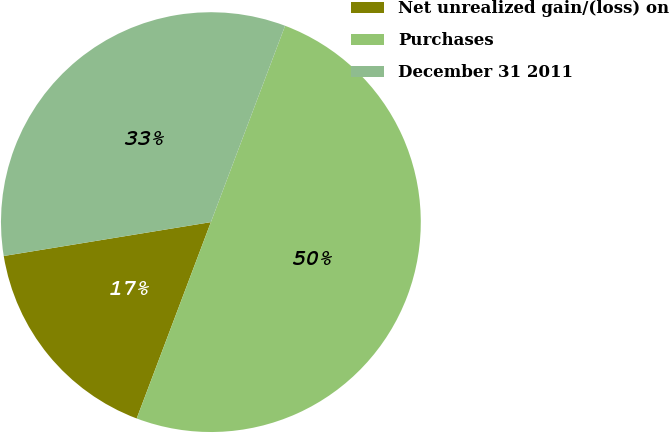Convert chart. <chart><loc_0><loc_0><loc_500><loc_500><pie_chart><fcel>Net unrealized gain/(loss) on<fcel>Purchases<fcel>December 31 2011<nl><fcel>16.67%<fcel>50.0%<fcel>33.33%<nl></chart> 